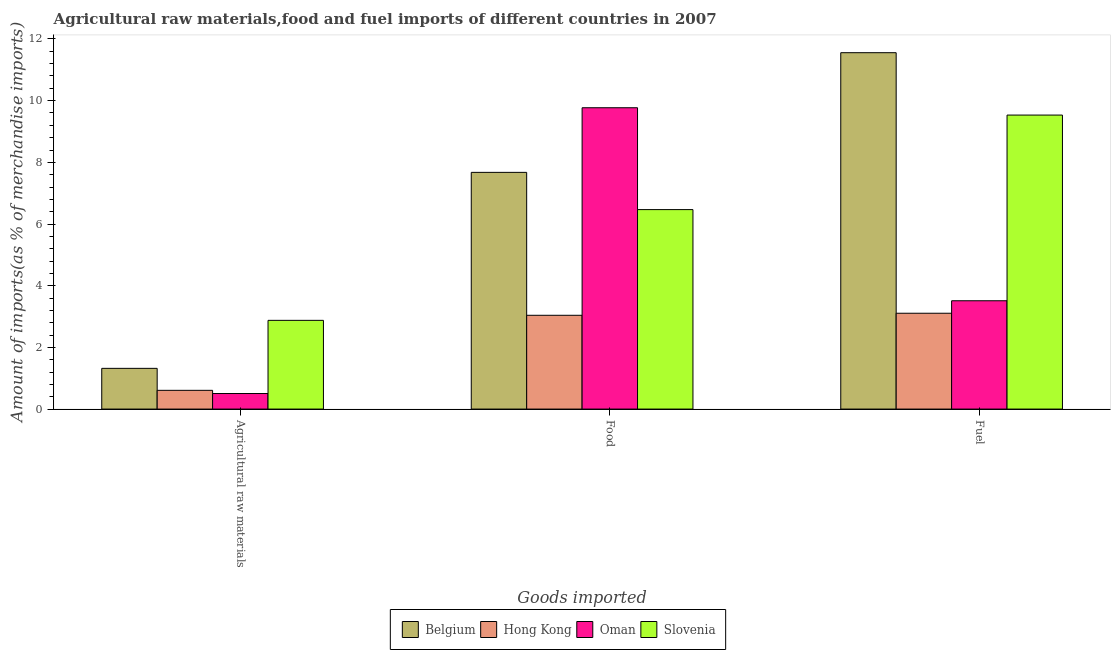How many different coloured bars are there?
Offer a terse response. 4. Are the number of bars per tick equal to the number of legend labels?
Keep it short and to the point. Yes. Are the number of bars on each tick of the X-axis equal?
Your answer should be compact. Yes. How many bars are there on the 3rd tick from the right?
Provide a short and direct response. 4. What is the label of the 2nd group of bars from the left?
Offer a terse response. Food. What is the percentage of raw materials imports in Oman?
Offer a very short reply. 0.5. Across all countries, what is the maximum percentage of raw materials imports?
Offer a very short reply. 2.88. Across all countries, what is the minimum percentage of fuel imports?
Your response must be concise. 3.11. In which country was the percentage of fuel imports maximum?
Provide a short and direct response. Belgium. In which country was the percentage of food imports minimum?
Your response must be concise. Hong Kong. What is the total percentage of raw materials imports in the graph?
Offer a very short reply. 5.31. What is the difference between the percentage of raw materials imports in Oman and that in Belgium?
Your answer should be very brief. -0.82. What is the difference between the percentage of raw materials imports in Oman and the percentage of food imports in Belgium?
Offer a very short reply. -7.17. What is the average percentage of fuel imports per country?
Give a very brief answer. 6.93. What is the difference between the percentage of food imports and percentage of fuel imports in Slovenia?
Offer a very short reply. -3.07. What is the ratio of the percentage of food imports in Slovenia to that in Hong Kong?
Your response must be concise. 2.13. What is the difference between the highest and the second highest percentage of food imports?
Your answer should be very brief. 2.1. What is the difference between the highest and the lowest percentage of fuel imports?
Offer a terse response. 8.45. What does the 2nd bar from the left in Food represents?
Make the answer very short. Hong Kong. What does the 1st bar from the right in Fuel represents?
Offer a very short reply. Slovenia. How many bars are there?
Your answer should be compact. 12. Are all the bars in the graph horizontal?
Your response must be concise. No. How many countries are there in the graph?
Offer a very short reply. 4. What is the difference between two consecutive major ticks on the Y-axis?
Give a very brief answer. 2. How many legend labels are there?
Give a very brief answer. 4. How are the legend labels stacked?
Provide a succinct answer. Horizontal. What is the title of the graph?
Ensure brevity in your answer.  Agricultural raw materials,food and fuel imports of different countries in 2007. What is the label or title of the X-axis?
Your answer should be compact. Goods imported. What is the label or title of the Y-axis?
Your response must be concise. Amount of imports(as % of merchandise imports). What is the Amount of imports(as % of merchandise imports) in Belgium in Agricultural raw materials?
Your response must be concise. 1.32. What is the Amount of imports(as % of merchandise imports) in Hong Kong in Agricultural raw materials?
Your answer should be compact. 0.61. What is the Amount of imports(as % of merchandise imports) in Oman in Agricultural raw materials?
Ensure brevity in your answer.  0.5. What is the Amount of imports(as % of merchandise imports) in Slovenia in Agricultural raw materials?
Your answer should be very brief. 2.88. What is the Amount of imports(as % of merchandise imports) of Belgium in Food?
Your response must be concise. 7.67. What is the Amount of imports(as % of merchandise imports) in Hong Kong in Food?
Your answer should be very brief. 3.04. What is the Amount of imports(as % of merchandise imports) in Oman in Food?
Offer a very short reply. 9.77. What is the Amount of imports(as % of merchandise imports) in Slovenia in Food?
Make the answer very short. 6.47. What is the Amount of imports(as % of merchandise imports) of Belgium in Fuel?
Offer a terse response. 11.56. What is the Amount of imports(as % of merchandise imports) of Hong Kong in Fuel?
Your answer should be very brief. 3.11. What is the Amount of imports(as % of merchandise imports) in Oman in Fuel?
Make the answer very short. 3.51. What is the Amount of imports(as % of merchandise imports) of Slovenia in Fuel?
Keep it short and to the point. 9.53. Across all Goods imported, what is the maximum Amount of imports(as % of merchandise imports) of Belgium?
Ensure brevity in your answer.  11.56. Across all Goods imported, what is the maximum Amount of imports(as % of merchandise imports) of Hong Kong?
Your response must be concise. 3.11. Across all Goods imported, what is the maximum Amount of imports(as % of merchandise imports) in Oman?
Your response must be concise. 9.77. Across all Goods imported, what is the maximum Amount of imports(as % of merchandise imports) of Slovenia?
Provide a succinct answer. 9.53. Across all Goods imported, what is the minimum Amount of imports(as % of merchandise imports) in Belgium?
Keep it short and to the point. 1.32. Across all Goods imported, what is the minimum Amount of imports(as % of merchandise imports) in Hong Kong?
Ensure brevity in your answer.  0.61. Across all Goods imported, what is the minimum Amount of imports(as % of merchandise imports) of Oman?
Your answer should be very brief. 0.5. Across all Goods imported, what is the minimum Amount of imports(as % of merchandise imports) of Slovenia?
Make the answer very short. 2.88. What is the total Amount of imports(as % of merchandise imports) of Belgium in the graph?
Offer a terse response. 20.55. What is the total Amount of imports(as % of merchandise imports) in Hong Kong in the graph?
Your answer should be compact. 6.76. What is the total Amount of imports(as % of merchandise imports) of Oman in the graph?
Your response must be concise. 13.79. What is the total Amount of imports(as % of merchandise imports) of Slovenia in the graph?
Keep it short and to the point. 18.88. What is the difference between the Amount of imports(as % of merchandise imports) in Belgium in Agricultural raw materials and that in Food?
Provide a short and direct response. -6.35. What is the difference between the Amount of imports(as % of merchandise imports) in Hong Kong in Agricultural raw materials and that in Food?
Your answer should be very brief. -2.43. What is the difference between the Amount of imports(as % of merchandise imports) in Oman in Agricultural raw materials and that in Food?
Keep it short and to the point. -9.27. What is the difference between the Amount of imports(as % of merchandise imports) of Slovenia in Agricultural raw materials and that in Food?
Offer a terse response. -3.59. What is the difference between the Amount of imports(as % of merchandise imports) in Belgium in Agricultural raw materials and that in Fuel?
Your answer should be compact. -10.23. What is the difference between the Amount of imports(as % of merchandise imports) of Hong Kong in Agricultural raw materials and that in Fuel?
Provide a succinct answer. -2.5. What is the difference between the Amount of imports(as % of merchandise imports) of Oman in Agricultural raw materials and that in Fuel?
Offer a terse response. -3.01. What is the difference between the Amount of imports(as % of merchandise imports) of Slovenia in Agricultural raw materials and that in Fuel?
Offer a terse response. -6.66. What is the difference between the Amount of imports(as % of merchandise imports) in Belgium in Food and that in Fuel?
Keep it short and to the point. -3.88. What is the difference between the Amount of imports(as % of merchandise imports) in Hong Kong in Food and that in Fuel?
Provide a succinct answer. -0.07. What is the difference between the Amount of imports(as % of merchandise imports) in Oman in Food and that in Fuel?
Your answer should be very brief. 6.26. What is the difference between the Amount of imports(as % of merchandise imports) of Slovenia in Food and that in Fuel?
Your answer should be compact. -3.07. What is the difference between the Amount of imports(as % of merchandise imports) in Belgium in Agricultural raw materials and the Amount of imports(as % of merchandise imports) in Hong Kong in Food?
Offer a terse response. -1.72. What is the difference between the Amount of imports(as % of merchandise imports) of Belgium in Agricultural raw materials and the Amount of imports(as % of merchandise imports) of Oman in Food?
Offer a very short reply. -8.45. What is the difference between the Amount of imports(as % of merchandise imports) of Belgium in Agricultural raw materials and the Amount of imports(as % of merchandise imports) of Slovenia in Food?
Your response must be concise. -5.15. What is the difference between the Amount of imports(as % of merchandise imports) in Hong Kong in Agricultural raw materials and the Amount of imports(as % of merchandise imports) in Oman in Food?
Make the answer very short. -9.16. What is the difference between the Amount of imports(as % of merchandise imports) in Hong Kong in Agricultural raw materials and the Amount of imports(as % of merchandise imports) in Slovenia in Food?
Provide a short and direct response. -5.86. What is the difference between the Amount of imports(as % of merchandise imports) of Oman in Agricultural raw materials and the Amount of imports(as % of merchandise imports) of Slovenia in Food?
Make the answer very short. -5.96. What is the difference between the Amount of imports(as % of merchandise imports) of Belgium in Agricultural raw materials and the Amount of imports(as % of merchandise imports) of Hong Kong in Fuel?
Your response must be concise. -1.79. What is the difference between the Amount of imports(as % of merchandise imports) in Belgium in Agricultural raw materials and the Amount of imports(as % of merchandise imports) in Oman in Fuel?
Provide a short and direct response. -2.19. What is the difference between the Amount of imports(as % of merchandise imports) of Belgium in Agricultural raw materials and the Amount of imports(as % of merchandise imports) of Slovenia in Fuel?
Offer a terse response. -8.21. What is the difference between the Amount of imports(as % of merchandise imports) of Hong Kong in Agricultural raw materials and the Amount of imports(as % of merchandise imports) of Oman in Fuel?
Offer a terse response. -2.9. What is the difference between the Amount of imports(as % of merchandise imports) in Hong Kong in Agricultural raw materials and the Amount of imports(as % of merchandise imports) in Slovenia in Fuel?
Your response must be concise. -8.93. What is the difference between the Amount of imports(as % of merchandise imports) in Oman in Agricultural raw materials and the Amount of imports(as % of merchandise imports) in Slovenia in Fuel?
Give a very brief answer. -9.03. What is the difference between the Amount of imports(as % of merchandise imports) in Belgium in Food and the Amount of imports(as % of merchandise imports) in Hong Kong in Fuel?
Offer a very short reply. 4.57. What is the difference between the Amount of imports(as % of merchandise imports) of Belgium in Food and the Amount of imports(as % of merchandise imports) of Oman in Fuel?
Ensure brevity in your answer.  4.16. What is the difference between the Amount of imports(as % of merchandise imports) in Belgium in Food and the Amount of imports(as % of merchandise imports) in Slovenia in Fuel?
Provide a succinct answer. -1.86. What is the difference between the Amount of imports(as % of merchandise imports) in Hong Kong in Food and the Amount of imports(as % of merchandise imports) in Oman in Fuel?
Your answer should be compact. -0.47. What is the difference between the Amount of imports(as % of merchandise imports) in Hong Kong in Food and the Amount of imports(as % of merchandise imports) in Slovenia in Fuel?
Offer a terse response. -6.49. What is the difference between the Amount of imports(as % of merchandise imports) of Oman in Food and the Amount of imports(as % of merchandise imports) of Slovenia in Fuel?
Ensure brevity in your answer.  0.24. What is the average Amount of imports(as % of merchandise imports) in Belgium per Goods imported?
Offer a very short reply. 6.85. What is the average Amount of imports(as % of merchandise imports) in Hong Kong per Goods imported?
Your answer should be very brief. 2.25. What is the average Amount of imports(as % of merchandise imports) in Oman per Goods imported?
Your answer should be very brief. 4.6. What is the average Amount of imports(as % of merchandise imports) in Slovenia per Goods imported?
Give a very brief answer. 6.29. What is the difference between the Amount of imports(as % of merchandise imports) in Belgium and Amount of imports(as % of merchandise imports) in Hong Kong in Agricultural raw materials?
Offer a terse response. 0.71. What is the difference between the Amount of imports(as % of merchandise imports) of Belgium and Amount of imports(as % of merchandise imports) of Oman in Agricultural raw materials?
Keep it short and to the point. 0.82. What is the difference between the Amount of imports(as % of merchandise imports) in Belgium and Amount of imports(as % of merchandise imports) in Slovenia in Agricultural raw materials?
Your answer should be very brief. -1.56. What is the difference between the Amount of imports(as % of merchandise imports) in Hong Kong and Amount of imports(as % of merchandise imports) in Oman in Agricultural raw materials?
Give a very brief answer. 0.1. What is the difference between the Amount of imports(as % of merchandise imports) in Hong Kong and Amount of imports(as % of merchandise imports) in Slovenia in Agricultural raw materials?
Offer a very short reply. -2.27. What is the difference between the Amount of imports(as % of merchandise imports) in Oman and Amount of imports(as % of merchandise imports) in Slovenia in Agricultural raw materials?
Provide a short and direct response. -2.37. What is the difference between the Amount of imports(as % of merchandise imports) in Belgium and Amount of imports(as % of merchandise imports) in Hong Kong in Food?
Ensure brevity in your answer.  4.63. What is the difference between the Amount of imports(as % of merchandise imports) in Belgium and Amount of imports(as % of merchandise imports) in Oman in Food?
Ensure brevity in your answer.  -2.1. What is the difference between the Amount of imports(as % of merchandise imports) in Belgium and Amount of imports(as % of merchandise imports) in Slovenia in Food?
Offer a very short reply. 1.21. What is the difference between the Amount of imports(as % of merchandise imports) of Hong Kong and Amount of imports(as % of merchandise imports) of Oman in Food?
Provide a succinct answer. -6.73. What is the difference between the Amount of imports(as % of merchandise imports) of Hong Kong and Amount of imports(as % of merchandise imports) of Slovenia in Food?
Provide a succinct answer. -3.43. What is the difference between the Amount of imports(as % of merchandise imports) in Oman and Amount of imports(as % of merchandise imports) in Slovenia in Food?
Offer a very short reply. 3.3. What is the difference between the Amount of imports(as % of merchandise imports) in Belgium and Amount of imports(as % of merchandise imports) in Hong Kong in Fuel?
Your answer should be compact. 8.45. What is the difference between the Amount of imports(as % of merchandise imports) of Belgium and Amount of imports(as % of merchandise imports) of Oman in Fuel?
Keep it short and to the point. 8.04. What is the difference between the Amount of imports(as % of merchandise imports) in Belgium and Amount of imports(as % of merchandise imports) in Slovenia in Fuel?
Keep it short and to the point. 2.02. What is the difference between the Amount of imports(as % of merchandise imports) of Hong Kong and Amount of imports(as % of merchandise imports) of Oman in Fuel?
Your answer should be very brief. -0.4. What is the difference between the Amount of imports(as % of merchandise imports) in Hong Kong and Amount of imports(as % of merchandise imports) in Slovenia in Fuel?
Your answer should be compact. -6.43. What is the difference between the Amount of imports(as % of merchandise imports) of Oman and Amount of imports(as % of merchandise imports) of Slovenia in Fuel?
Give a very brief answer. -6.02. What is the ratio of the Amount of imports(as % of merchandise imports) of Belgium in Agricultural raw materials to that in Food?
Your answer should be compact. 0.17. What is the ratio of the Amount of imports(as % of merchandise imports) of Hong Kong in Agricultural raw materials to that in Food?
Ensure brevity in your answer.  0.2. What is the ratio of the Amount of imports(as % of merchandise imports) in Oman in Agricultural raw materials to that in Food?
Your answer should be compact. 0.05. What is the ratio of the Amount of imports(as % of merchandise imports) in Slovenia in Agricultural raw materials to that in Food?
Offer a terse response. 0.44. What is the ratio of the Amount of imports(as % of merchandise imports) in Belgium in Agricultural raw materials to that in Fuel?
Your answer should be very brief. 0.11. What is the ratio of the Amount of imports(as % of merchandise imports) in Hong Kong in Agricultural raw materials to that in Fuel?
Offer a very short reply. 0.2. What is the ratio of the Amount of imports(as % of merchandise imports) of Oman in Agricultural raw materials to that in Fuel?
Provide a succinct answer. 0.14. What is the ratio of the Amount of imports(as % of merchandise imports) of Slovenia in Agricultural raw materials to that in Fuel?
Your answer should be compact. 0.3. What is the ratio of the Amount of imports(as % of merchandise imports) in Belgium in Food to that in Fuel?
Make the answer very short. 0.66. What is the ratio of the Amount of imports(as % of merchandise imports) of Hong Kong in Food to that in Fuel?
Provide a succinct answer. 0.98. What is the ratio of the Amount of imports(as % of merchandise imports) of Oman in Food to that in Fuel?
Provide a succinct answer. 2.78. What is the ratio of the Amount of imports(as % of merchandise imports) of Slovenia in Food to that in Fuel?
Give a very brief answer. 0.68. What is the difference between the highest and the second highest Amount of imports(as % of merchandise imports) in Belgium?
Provide a short and direct response. 3.88. What is the difference between the highest and the second highest Amount of imports(as % of merchandise imports) in Hong Kong?
Your answer should be very brief. 0.07. What is the difference between the highest and the second highest Amount of imports(as % of merchandise imports) of Oman?
Offer a terse response. 6.26. What is the difference between the highest and the second highest Amount of imports(as % of merchandise imports) of Slovenia?
Keep it short and to the point. 3.07. What is the difference between the highest and the lowest Amount of imports(as % of merchandise imports) in Belgium?
Keep it short and to the point. 10.23. What is the difference between the highest and the lowest Amount of imports(as % of merchandise imports) in Hong Kong?
Your answer should be very brief. 2.5. What is the difference between the highest and the lowest Amount of imports(as % of merchandise imports) in Oman?
Provide a succinct answer. 9.27. What is the difference between the highest and the lowest Amount of imports(as % of merchandise imports) in Slovenia?
Ensure brevity in your answer.  6.66. 